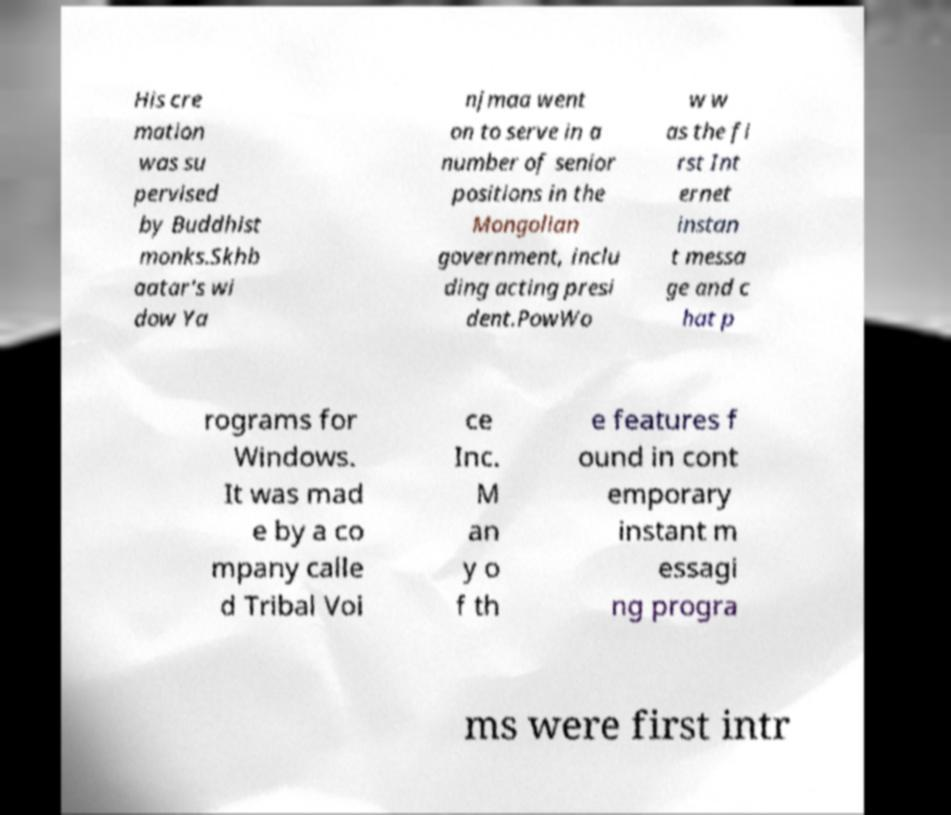There's text embedded in this image that I need extracted. Can you transcribe it verbatim? His cre mation was su pervised by Buddhist monks.Skhb aatar's wi dow Ya njmaa went on to serve in a number of senior positions in the Mongolian government, inclu ding acting presi dent.PowWo w w as the fi rst Int ernet instan t messa ge and c hat p rograms for Windows. It was mad e by a co mpany calle d Tribal Voi ce Inc. M an y o f th e features f ound in cont emporary instant m essagi ng progra ms were first intr 